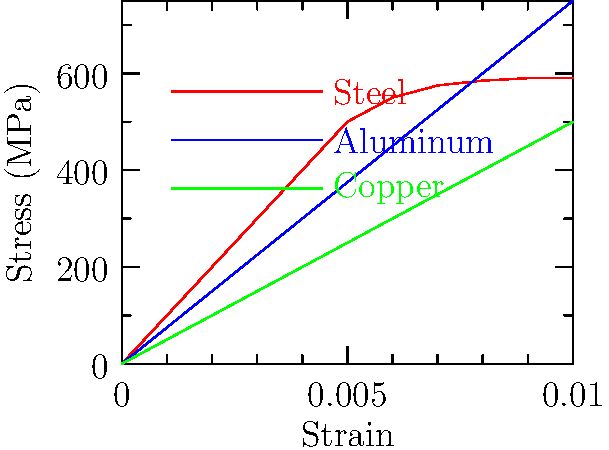As a master welder, you're working on a project that requires understanding the stress-strain characteristics of different metals. Given the stress-strain curves for steel, aluminum, and copper shown in the graph, which metal would be most suitable for a structure that needs to withstand high stress while minimizing permanent deformation? Explain your reasoning based on the yield strength and elastic region of each material. To answer this question, we need to analyze the stress-strain curves for each metal:

1. Identify the key features of the stress-strain curve:
   - The elastic region: The initial linear portion of the curve
   - The yield point: Where the curve begins to deviate from linearity
   - The ultimate strength: The highest point on the curve

2. Analyze each metal:
   a) Steel (red curve):
      - Has the steepest initial slope, indicating high stiffness
      - Highest yield strength (around 500 MPa)
      - Large elastic region before yielding

   b) Aluminum (blue curve):
      - Moderate initial slope
      - Lower yield strength (around 300 MPa)
      - Smaller elastic region compared to steel

   c) Copper (green curve):
      - Lowest initial slope
      - Lowest yield strength (around 200 MPa)
      - Smallest elastic region among the three

3. Consider the requirements:
   - Need to withstand high stress
   - Minimize permanent deformation

4. Make a decision:
   Steel is the most suitable material because:
   - It has the highest yield strength, allowing it to withstand higher stresses before permanent deformation occurs
   - It has the largest elastic region, meaning it can handle more stress while still returning to its original shape when the stress is removed

5. Implications for welding:
   As a master welder, you should be aware that steel's high yield strength and large elastic region make it ideal for structures requiring high stress resistance. However, it may also require higher welding temperatures and specific welding techniques compared to aluminum or copper.
Answer: Steel, due to its highest yield strength and largest elastic region. 